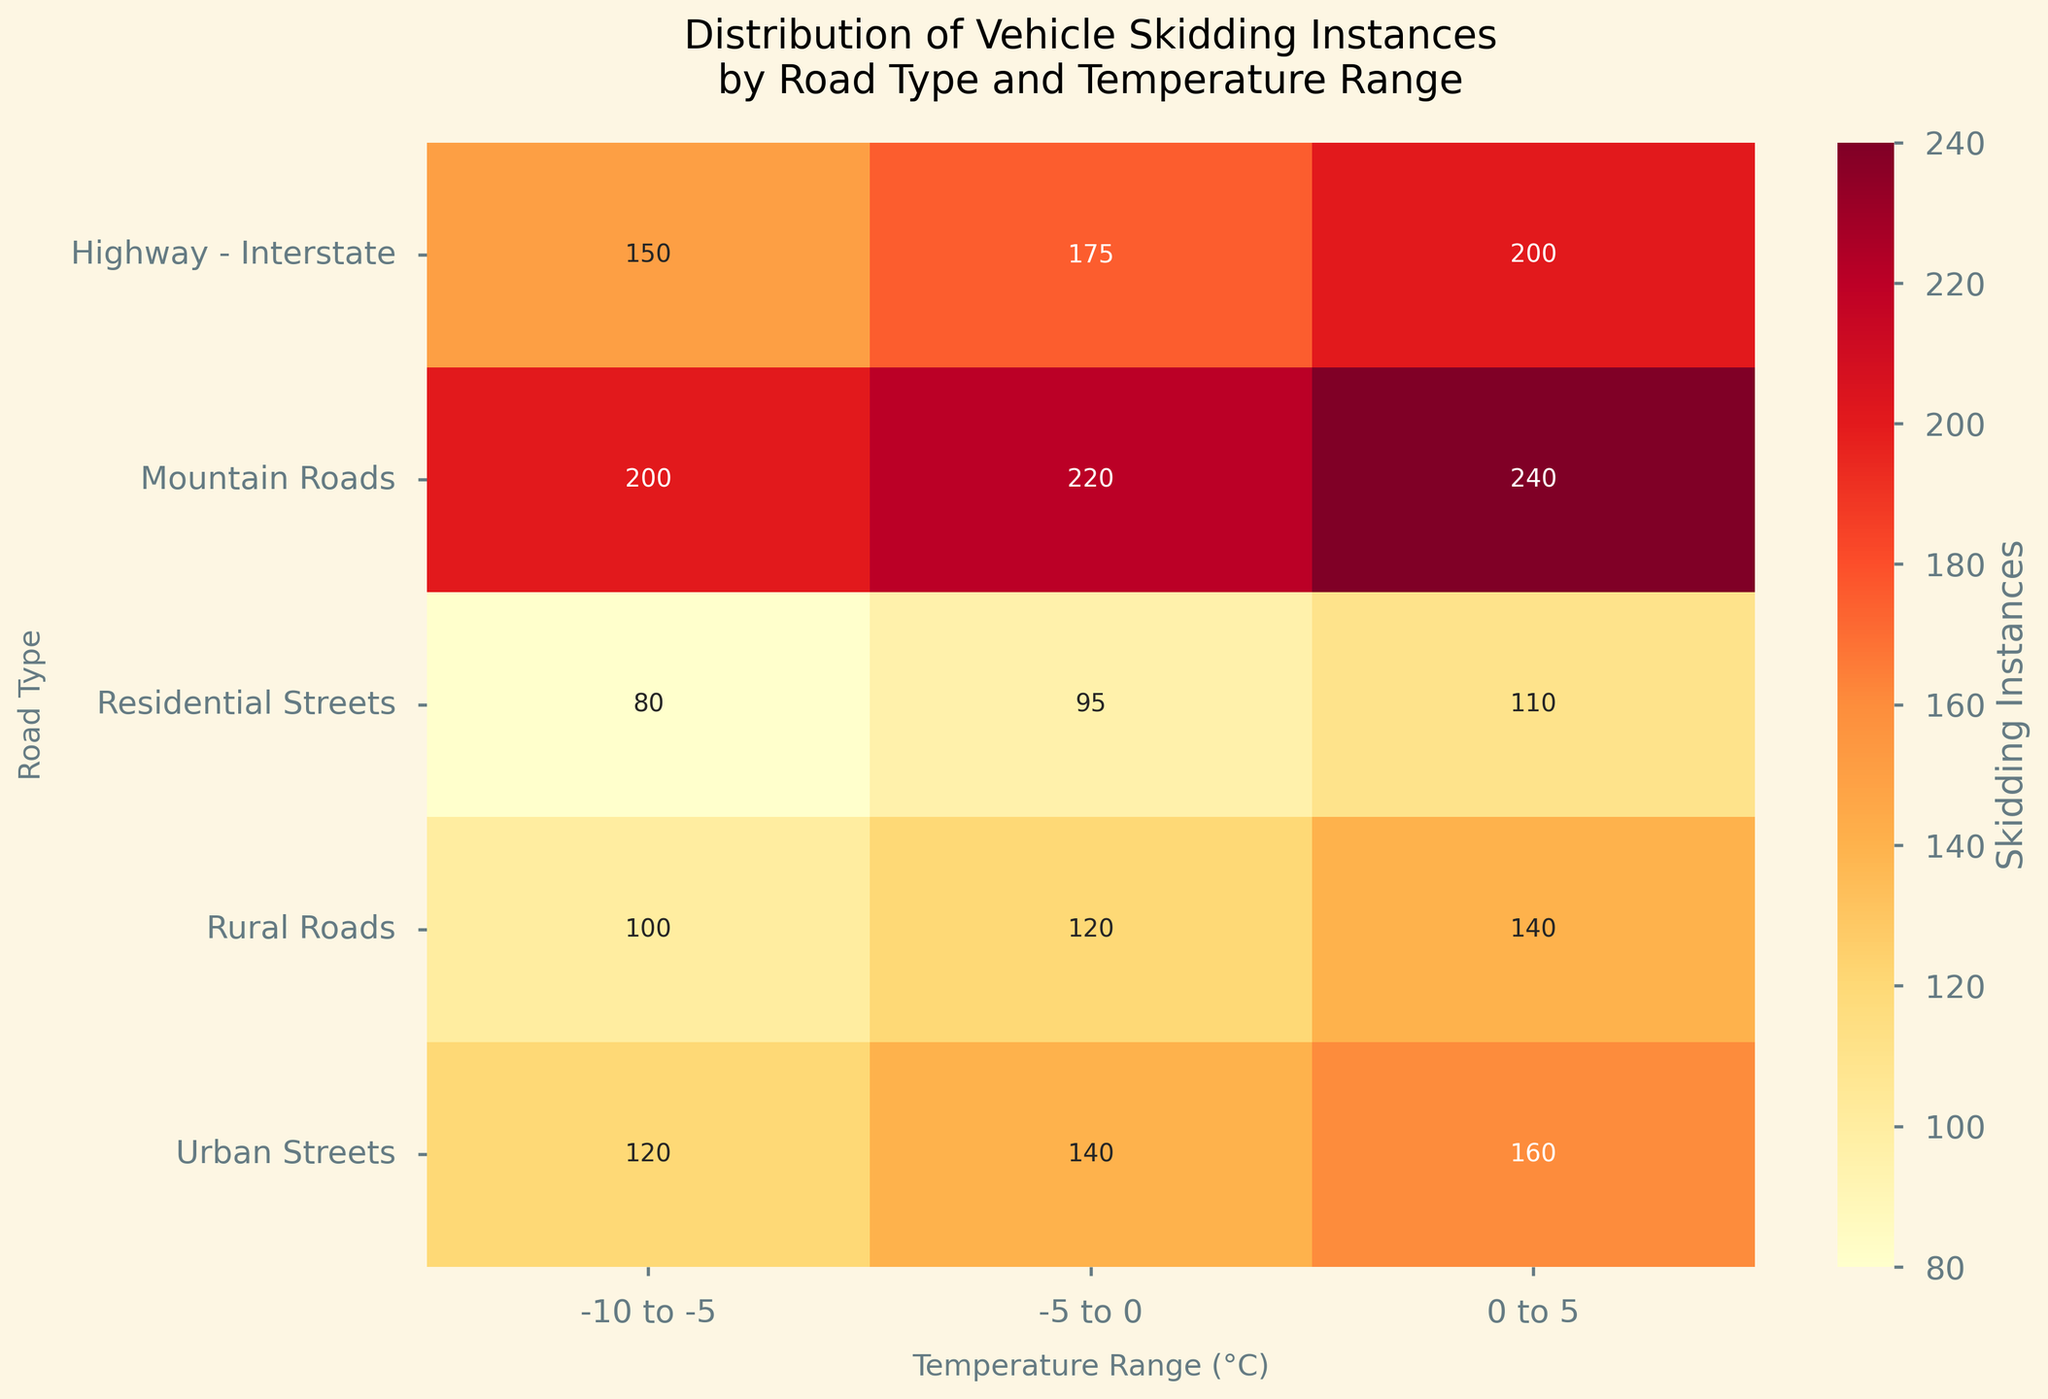What is the title of the heatmap? The title is typically at the top of the chart, clearly indicating the purpose or contents of the heatmap.
Answer: Distribution of Vehicle Skidding Instances by Road Type and Temperature Range Which Temperature Range has the highest skidding instances on Mountain Roads? Look at the Mountain Roads row and identify the temperature range column with the highest value. The highest number in this row is 240, which corresponds to the 0 to 5°C temperature range.
Answer: 0 to 5 How many skidding instances are recorded for Urban Streets across all temperature ranges? To solve this, sum the skidding instances for Urban Streets across all temperature ranges: 120 (for -10 to -5°C) + 140 (for -5 to 0°C) + 160 (for 0 to 5°C).
Answer: 420 Which Road Type has the fewest skidding instances at the temperature range of -10 to -5°C? Look down the -10 to -5°C column and find the Road Type with the smallest value. The smallest value is 80, which corresponds to Residential Streets.
Answer: Residential Streets For which Road Type and Temperature Range combination is the skidding instance 95? Identify the cell in the heatmap with the number 95, and then check its corresponding Road Type row and Temperature Range column. The value 95 is located at the intersection of Residential Streets and the -5 to 0°C temperature range.
Answer: Residential Streets, -5 to 0 How many more skidding instances occur on Rural Roads at 0 to 5°C compared to -5 to 0°C? First, find the skidding instances for Rural Roads at 0 to 5°C (140) and at -5 to 0°C (120). Subtract the latter from the former: 140 - 120.
Answer: 20 Among all Road Types, which one has the greatest increase in skidding instances as the temperature range changes from -10 to -5°C to -5 to 0°C? Calculate the differences for each Road Type as temperature changes from -10 to -5°C to -5 to 0°C, then identify the largest. 
- Highway - Interstate: 175 - 150 = 25
- Urban Streets: 140 - 120 = 20
- Residential Streets: 95 - 80 = 15
- Mountain Roads: 220 - 200 = 20
- Rural Roads: 120 - 100 = 20
The greatest increase (25) is for the Highway - Interstate.
Answer: Highway - Interstate What is the average number of skidding instances for all road types at the temperature range of -5 to 0°C? Average the skidding instances at the -5 to 0°C temperature range: (175 + 140 + 95 + 220 + 120) / 5 = 150.
Answer: 150 